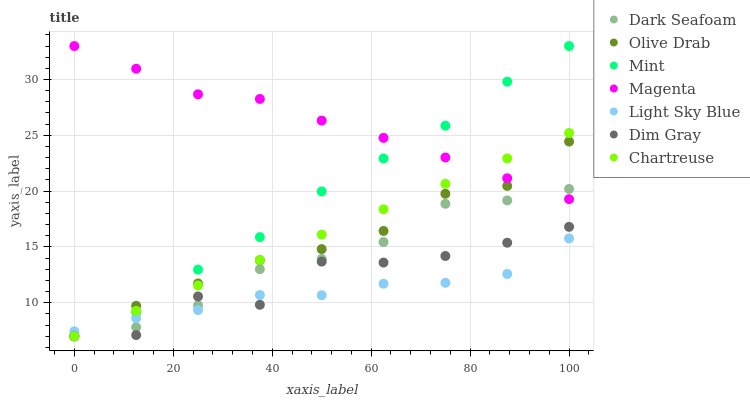Does Light Sky Blue have the minimum area under the curve?
Answer yes or no. Yes. Does Magenta have the maximum area under the curve?
Answer yes or no. Yes. Does Chartreuse have the minimum area under the curve?
Answer yes or no. No. Does Chartreuse have the maximum area under the curve?
Answer yes or no. No. Is Chartreuse the smoothest?
Answer yes or no. Yes. Is Dim Gray the roughest?
Answer yes or no. Yes. Is Dark Seafoam the smoothest?
Answer yes or no. No. Is Dark Seafoam the roughest?
Answer yes or no. No. Does Dim Gray have the lowest value?
Answer yes or no. Yes. Does Light Sky Blue have the lowest value?
Answer yes or no. No. Does Mint have the highest value?
Answer yes or no. Yes. Does Chartreuse have the highest value?
Answer yes or no. No. Is Dim Gray less than Magenta?
Answer yes or no. Yes. Is Magenta greater than Dim Gray?
Answer yes or no. Yes. Does Chartreuse intersect Magenta?
Answer yes or no. Yes. Is Chartreuse less than Magenta?
Answer yes or no. No. Is Chartreuse greater than Magenta?
Answer yes or no. No. Does Dim Gray intersect Magenta?
Answer yes or no. No. 